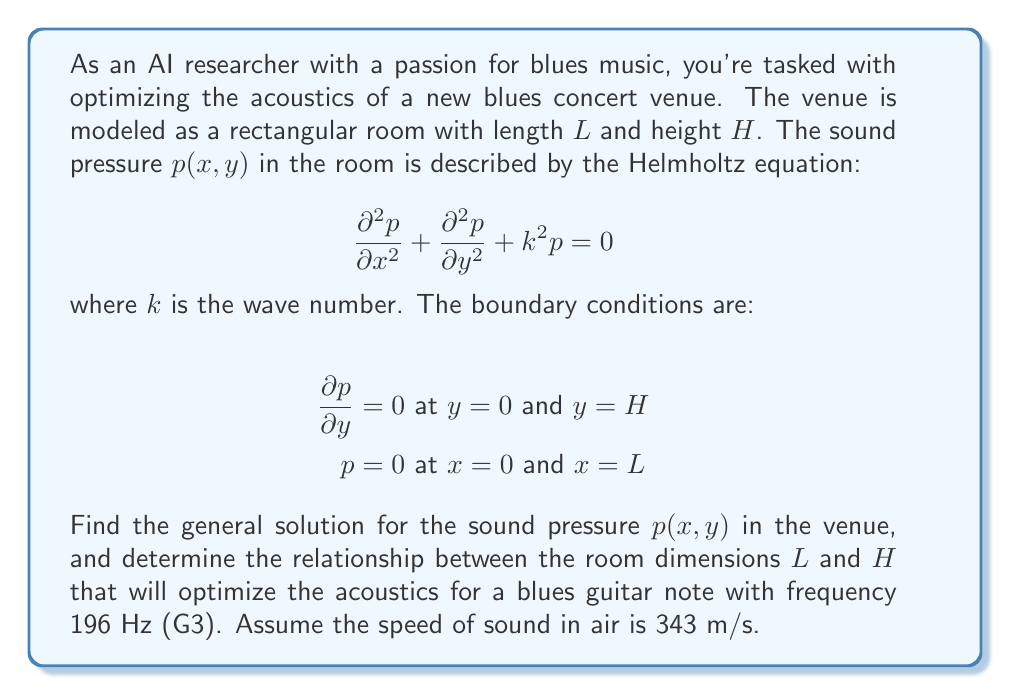Provide a solution to this math problem. Let's approach this problem step by step:

1) We start with the Helmholtz equation:

   $$\frac{\partial^2 p}{\partial x^2} + \frac{\partial^2 p}{\partial y^2} + k^2 p = 0$$

2) We can solve this using separation of variables. Let $p(x,y) = X(x)Y(y)$. Substituting this into the equation:

   $$Y\frac{d^2X}{dx^2} + X\frac{d^2Y}{dy^2} + k^2XY = 0$$

3) Dividing by $XY$:

   $$\frac{1}{X}\frac{d^2X}{dx^2} + \frac{1}{Y}\frac{d^2Y}{dy^2} + k^2 = 0$$

4) This equation must be true for all $x$ and $y$, so each term must be constant. Let's say:

   $$\frac{1}{X}\frac{d^2X}{dx^2} = -\alpha^2$$
   $$\frac{1}{Y}\frac{d^2Y}{dy^2} = -\beta^2$$

   where $\alpha^2 + \beta^2 = k^2$

5) Solving these ODEs with the given boundary conditions:

   For $X$: $X(x) = A\sin(\alpha x)$, with $\alpha = \frac{n\pi}{L}$, $n = 1,2,3,...$
   For $Y$: $Y(y) = B\cos(\beta y)$, with $\beta = \frac{m\pi}{H}$, $m = 0,1,2,...$

6) The general solution is:

   $$p(x,y) = \sum_{n=1}^{\infty}\sum_{m=0}^{\infty} A_{nm}\sin(\frac{n\pi x}{L})\cos(\frac{m\pi y}{H})$$

7) The relationship between $k$, $n$, $m$, $L$, and $H$ is:

   $$k^2 = (\frac{n\pi}{L})^2 + (\frac{m\pi}{H})^2$$

8) For the blues guitar note G3 (196 Hz):

   $$k = \frac{2\pi f}{c} = \frac{2\pi(196)}{343} \approx 3.59$$

9) To optimize the acoustics, we want the fundamental mode $(n=1, m=0)$ to match this frequency. This gives us:

   $$3.59^2 = (\frac{\pi}{L})^2 + 0^2$$

10) Solving for $L$:

    $$L = \frac{\pi}{3.59} \approx 0.87 \text{ meters}$$

The height $H$ can be chosen arbitrarily, but for good acoustics, it's often recommended to avoid simple integer ratios between room dimensions.
Answer: The general solution for the sound pressure is:

$$p(x,y) = \sum_{n=1}^{\infty}\sum_{m=0}^{\infty} A_{nm}\sin(\frac{n\pi x}{L})\cos(\frac{m\pi y}{H})$$

To optimize the acoustics for a 196 Hz note, the length of the room should be approximately 0.87 meters. The height can be chosen arbitrarily, but should avoid simple integer ratios with the length. 